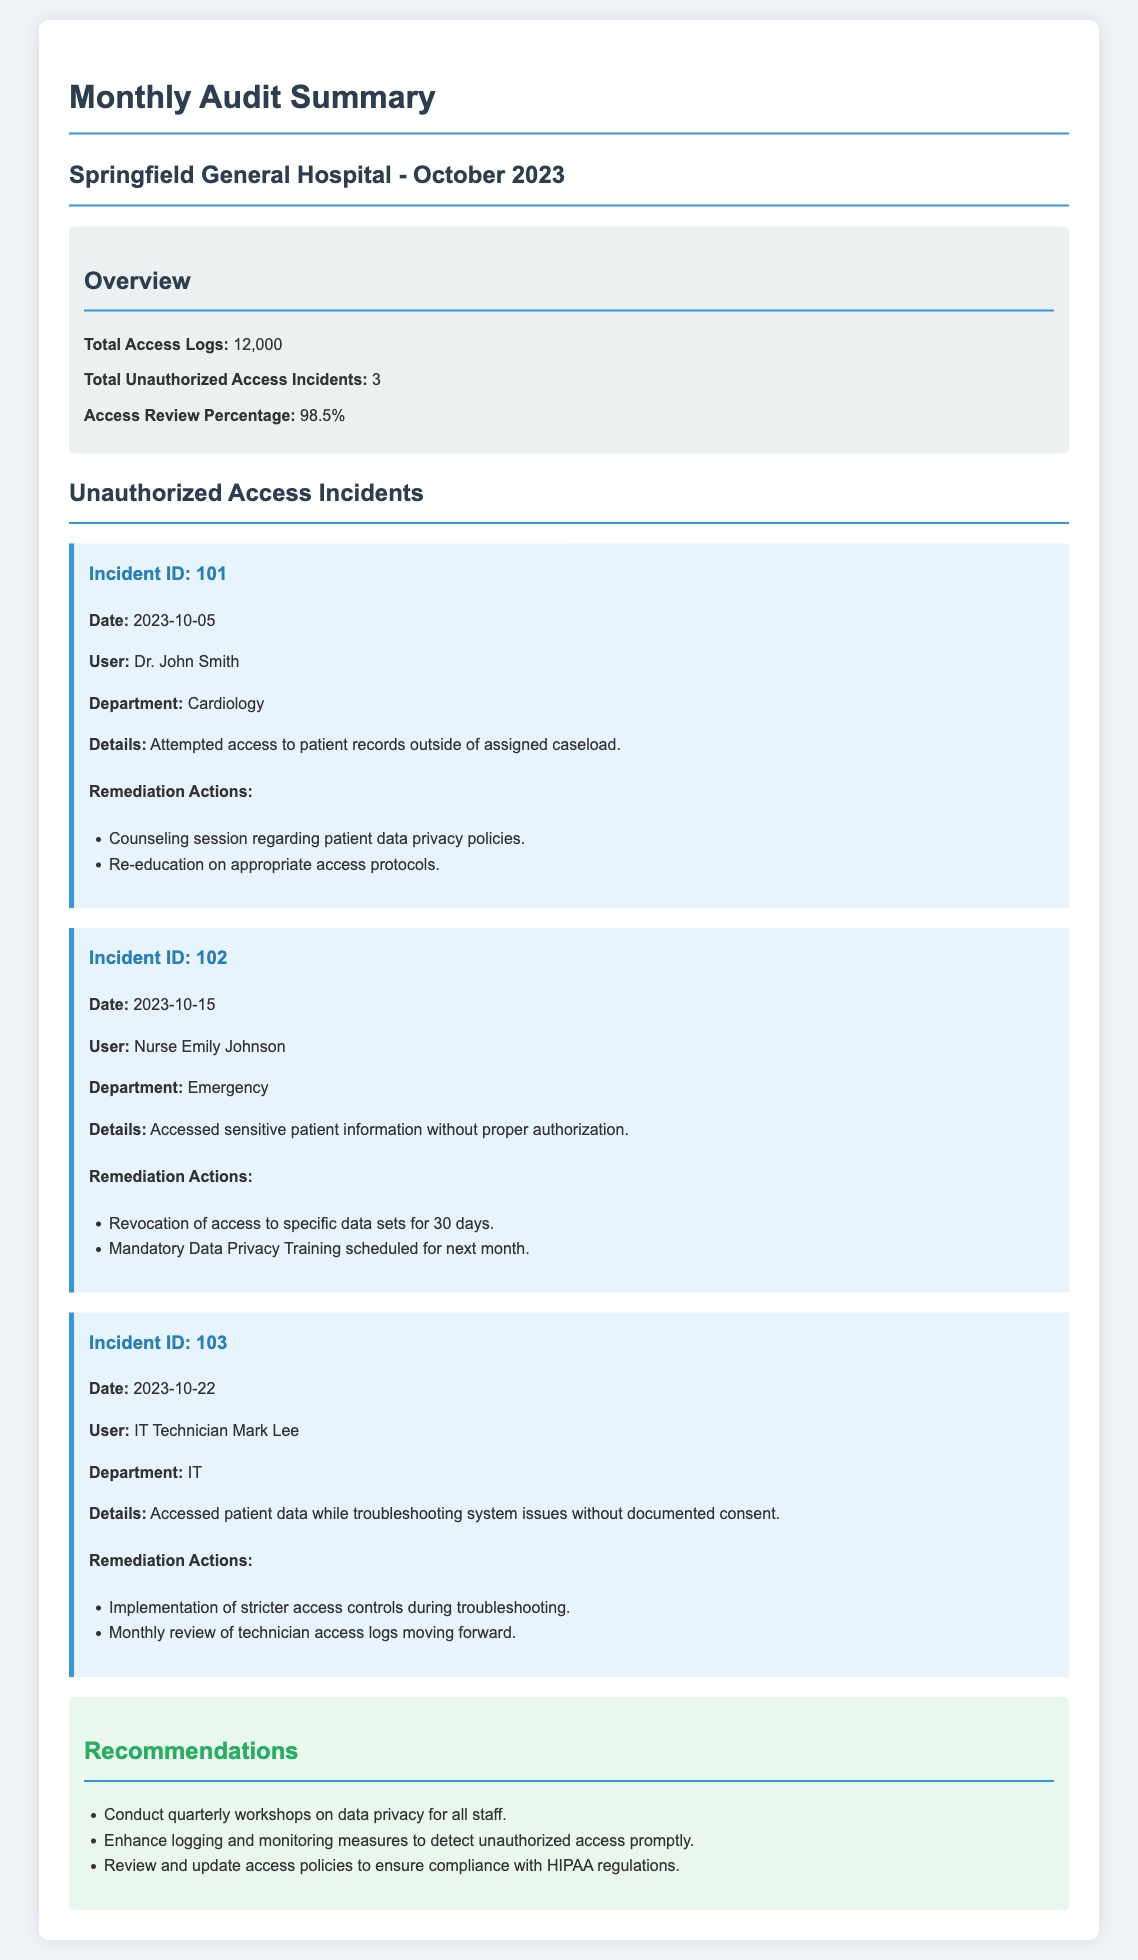What is the total number of access logs? The document states there were a total of 12,000 access logs recorded.
Answer: 12,000 How many unauthorized access incidents were reported? According to the overview section, there were 3 unauthorized access incidents.
Answer: 3 What was the access review percentage? The document indicates that the access review percentage is 98.5%.
Answer: 98.5% Who was involved in the first unauthorized access incident? The first incident involved Dr. John Smith, as noted in the incident details.
Answer: Dr. John Smith What was the date of the last unauthorized access incident? The last incident was reported on 2023-10-22 according to the incident details.
Answer: 2023-10-22 What remediation action was taken for Nurse Emily Johnson? Nurse Emily Johnson's access to specific data sets was revoked for 30 days as part of the remediation actions.
Answer: Revocation of access for 30 days What training was scheduled for Nurse Emily Johnson? A mandatory Data Privacy Training was scheduled for the following month as mentioned in her incident details.
Answer: Mandatory Data Privacy Training What are the recommendations for improving data privacy? Recommendations include conducting quarterly workshops and enhancing logging and monitoring measures.
Answer: Conduct quarterly workshops and enhance logging and monitoring measures What was the remediation action for IT Technician Mark Lee? The document states that implementation of stricter access controls was a remediation action taken for Mark Lee.
Answer: Implementation of stricter access controls 